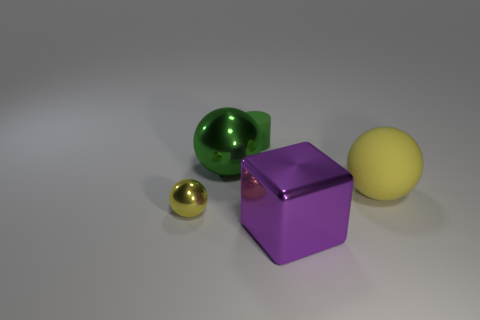Is there anything else that has the same shape as the large purple metallic object?
Your answer should be very brief. No. What number of objects are either big spheres on the right side of the large green thing or yellow things that are left of the matte sphere?
Offer a terse response. 2. Is the number of small balls to the left of the cylinder the same as the number of yellow things behind the yellow metal sphere?
Give a very brief answer. Yes. What shape is the yellow shiny thing that is in front of the yellow object that is behind the small ball?
Your response must be concise. Sphere. Is there a green metallic object that has the same shape as the tiny yellow metal thing?
Offer a terse response. Yes. How many cyan metal cubes are there?
Your answer should be very brief. 0. Do the tiny thing to the right of the large green metal thing and the big yellow thing have the same material?
Offer a terse response. Yes. Are there any yellow metallic spheres that have the same size as the green matte cylinder?
Provide a short and direct response. Yes. There is a green metal object; does it have the same shape as the yellow object that is on the left side of the large green thing?
Make the answer very short. Yes. There is a small thing in front of the big metal object that is on the left side of the big purple thing; are there any yellow spheres that are right of it?
Keep it short and to the point. Yes. 